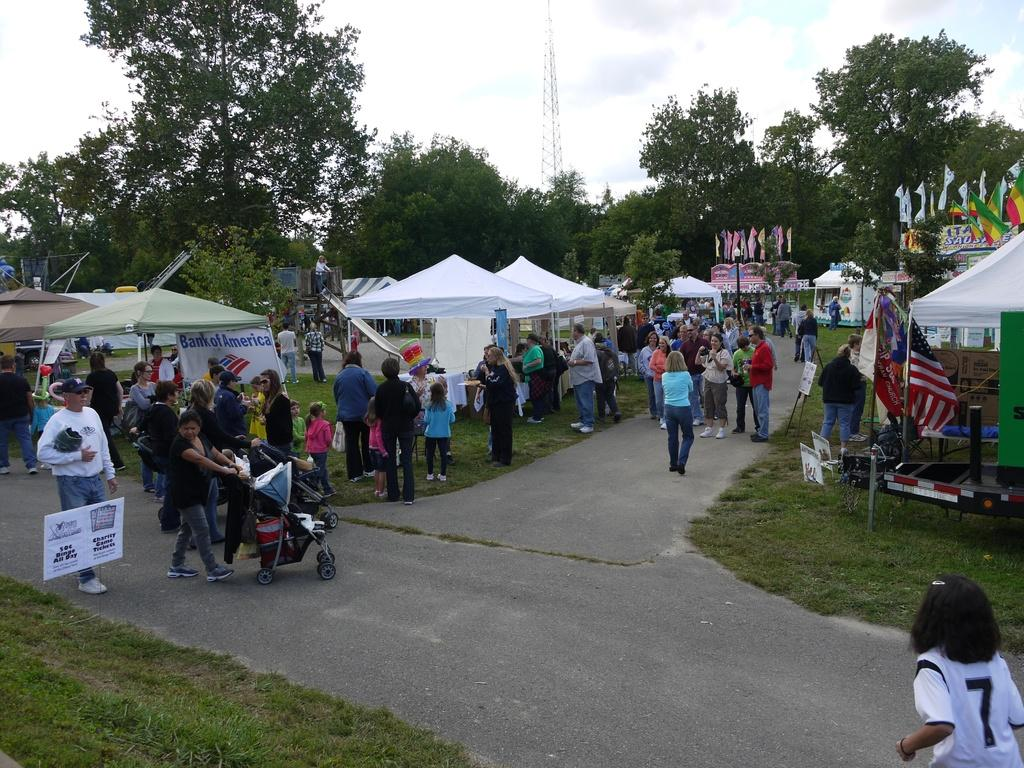What can be seen in the image? There are people, chairs, flags, baby chairs, tents, a board, and grass-covered ground in the image. What type of seating is available for children in the image? There are baby chairs in the image. What structures are present in the background of the image? There are trees in the background of the image. What is the surface of the ground in the image? The ground is covered with grass. What sense is being stimulated by the bat in the image? There is no bat present in the image, so it is not possible to answer that question. 